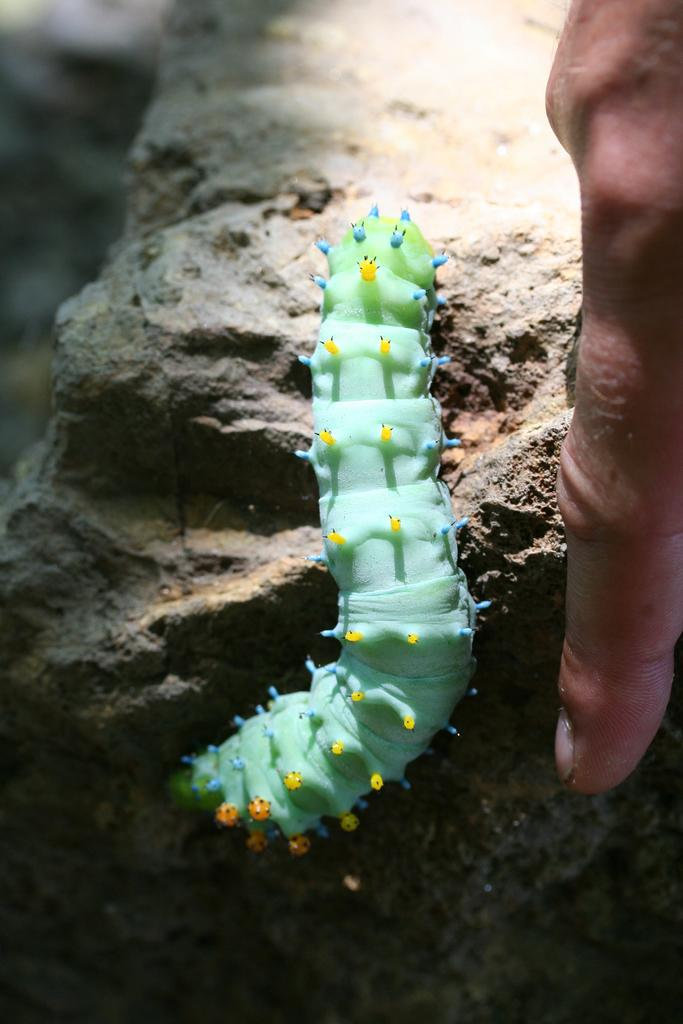What type of animal is present in the image? There is a caterpillar in the image. What color is the caterpillar? The caterpillar is blue in color. Can you describe anything else in the image? There is a person's hand on the right side of the image. What type of copper material can be seen in the image? There is no copper material present in the image. Can you describe the orange fruit in the image? There is no orange fruit present in the image. 